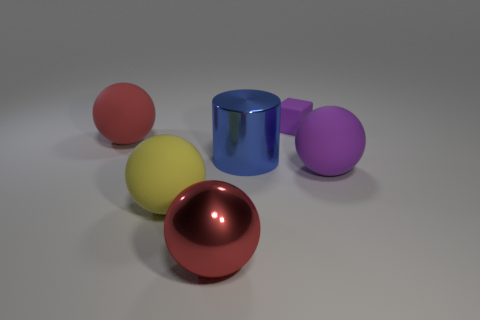How do the different colors of the objects affect the perception of depth in this image? The various colors in the image serve to distinguish each object clearly, with warmer colors like red appearing to advance towards the viewer, and cooler colors like blue seeming to recede into the background. This use of color can affect depth perception, creating a layered effect that enhances the three-dimensional quality of the image. 